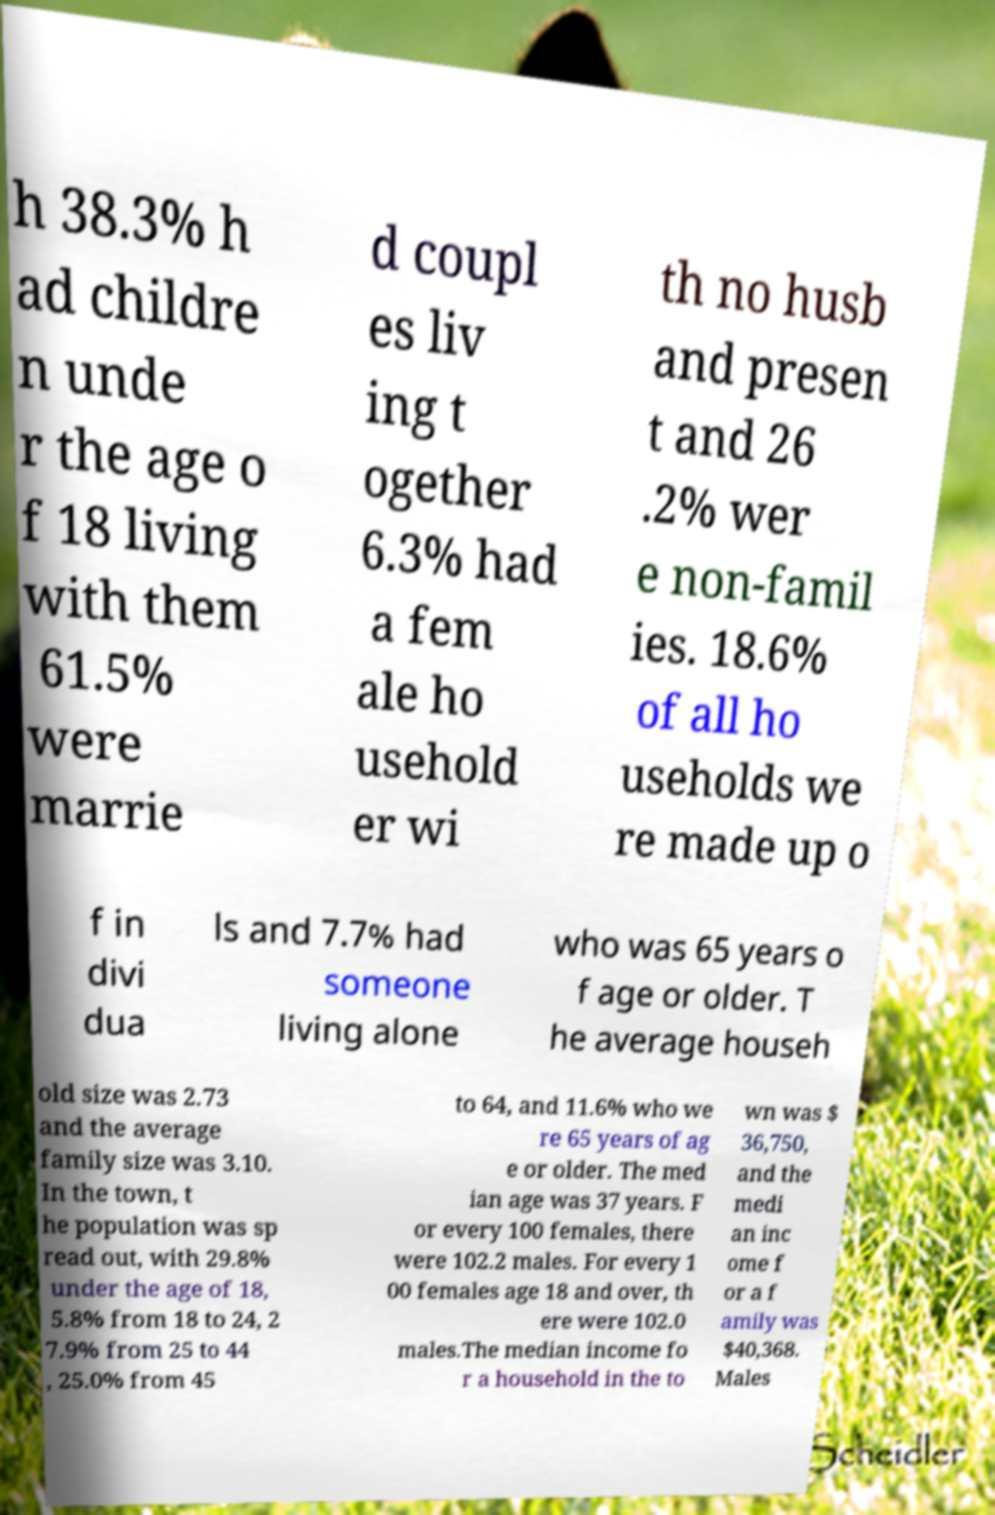Could you assist in decoding the text presented in this image and type it out clearly? h 38.3% h ad childre n unde r the age o f 18 living with them 61.5% were marrie d coupl es liv ing t ogether 6.3% had a fem ale ho usehold er wi th no husb and presen t and 26 .2% wer e non-famil ies. 18.6% of all ho useholds we re made up o f in divi dua ls and 7.7% had someone living alone who was 65 years o f age or older. T he average househ old size was 2.73 and the average family size was 3.10. In the town, t he population was sp read out, with 29.8% under the age of 18, 5.8% from 18 to 24, 2 7.9% from 25 to 44 , 25.0% from 45 to 64, and 11.6% who we re 65 years of ag e or older. The med ian age was 37 years. F or every 100 females, there were 102.2 males. For every 1 00 females age 18 and over, th ere were 102.0 males.The median income fo r a household in the to wn was $ 36,750, and the medi an inc ome f or a f amily was $40,368. Males 